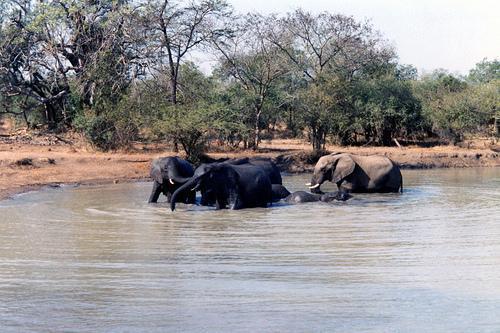How many elephants are in the picture?
Give a very brief answer. 5. 